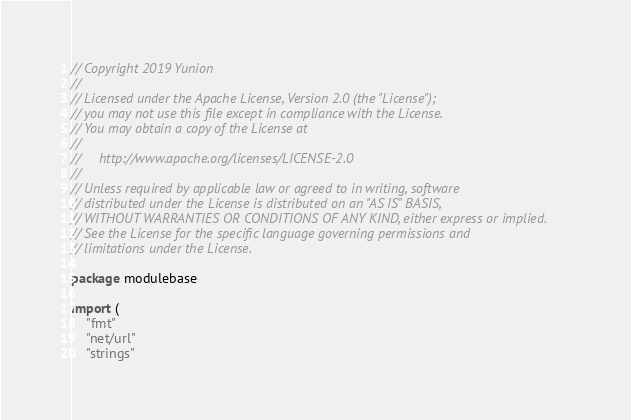Convert code to text. <code><loc_0><loc_0><loc_500><loc_500><_Go_>// Copyright 2019 Yunion
//
// Licensed under the Apache License, Version 2.0 (the "License");
// you may not use this file except in compliance with the License.
// You may obtain a copy of the License at
//
//     http://www.apache.org/licenses/LICENSE-2.0
//
// Unless required by applicable law or agreed to in writing, software
// distributed under the License is distributed on an "AS IS" BASIS,
// WITHOUT WARRANTIES OR CONDITIONS OF ANY KIND, either express or implied.
// See the License for the specific language governing permissions and
// limitations under the License.

package modulebase

import (
	"fmt"
	"net/url"
	"strings"
</code> 